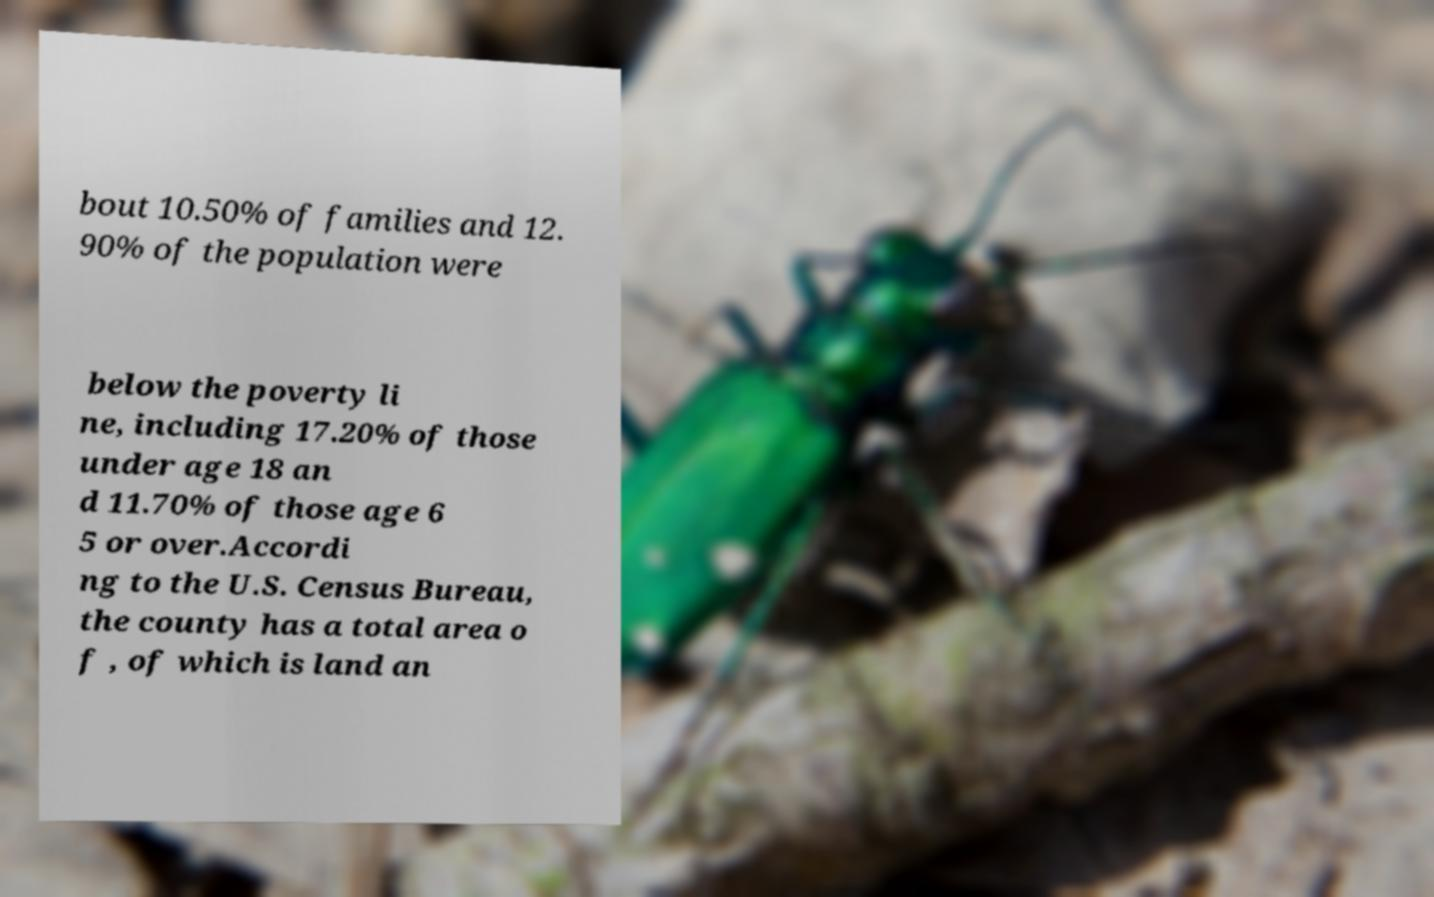What messages or text are displayed in this image? I need them in a readable, typed format. bout 10.50% of families and 12. 90% of the population were below the poverty li ne, including 17.20% of those under age 18 an d 11.70% of those age 6 5 or over.Accordi ng to the U.S. Census Bureau, the county has a total area o f , of which is land an 